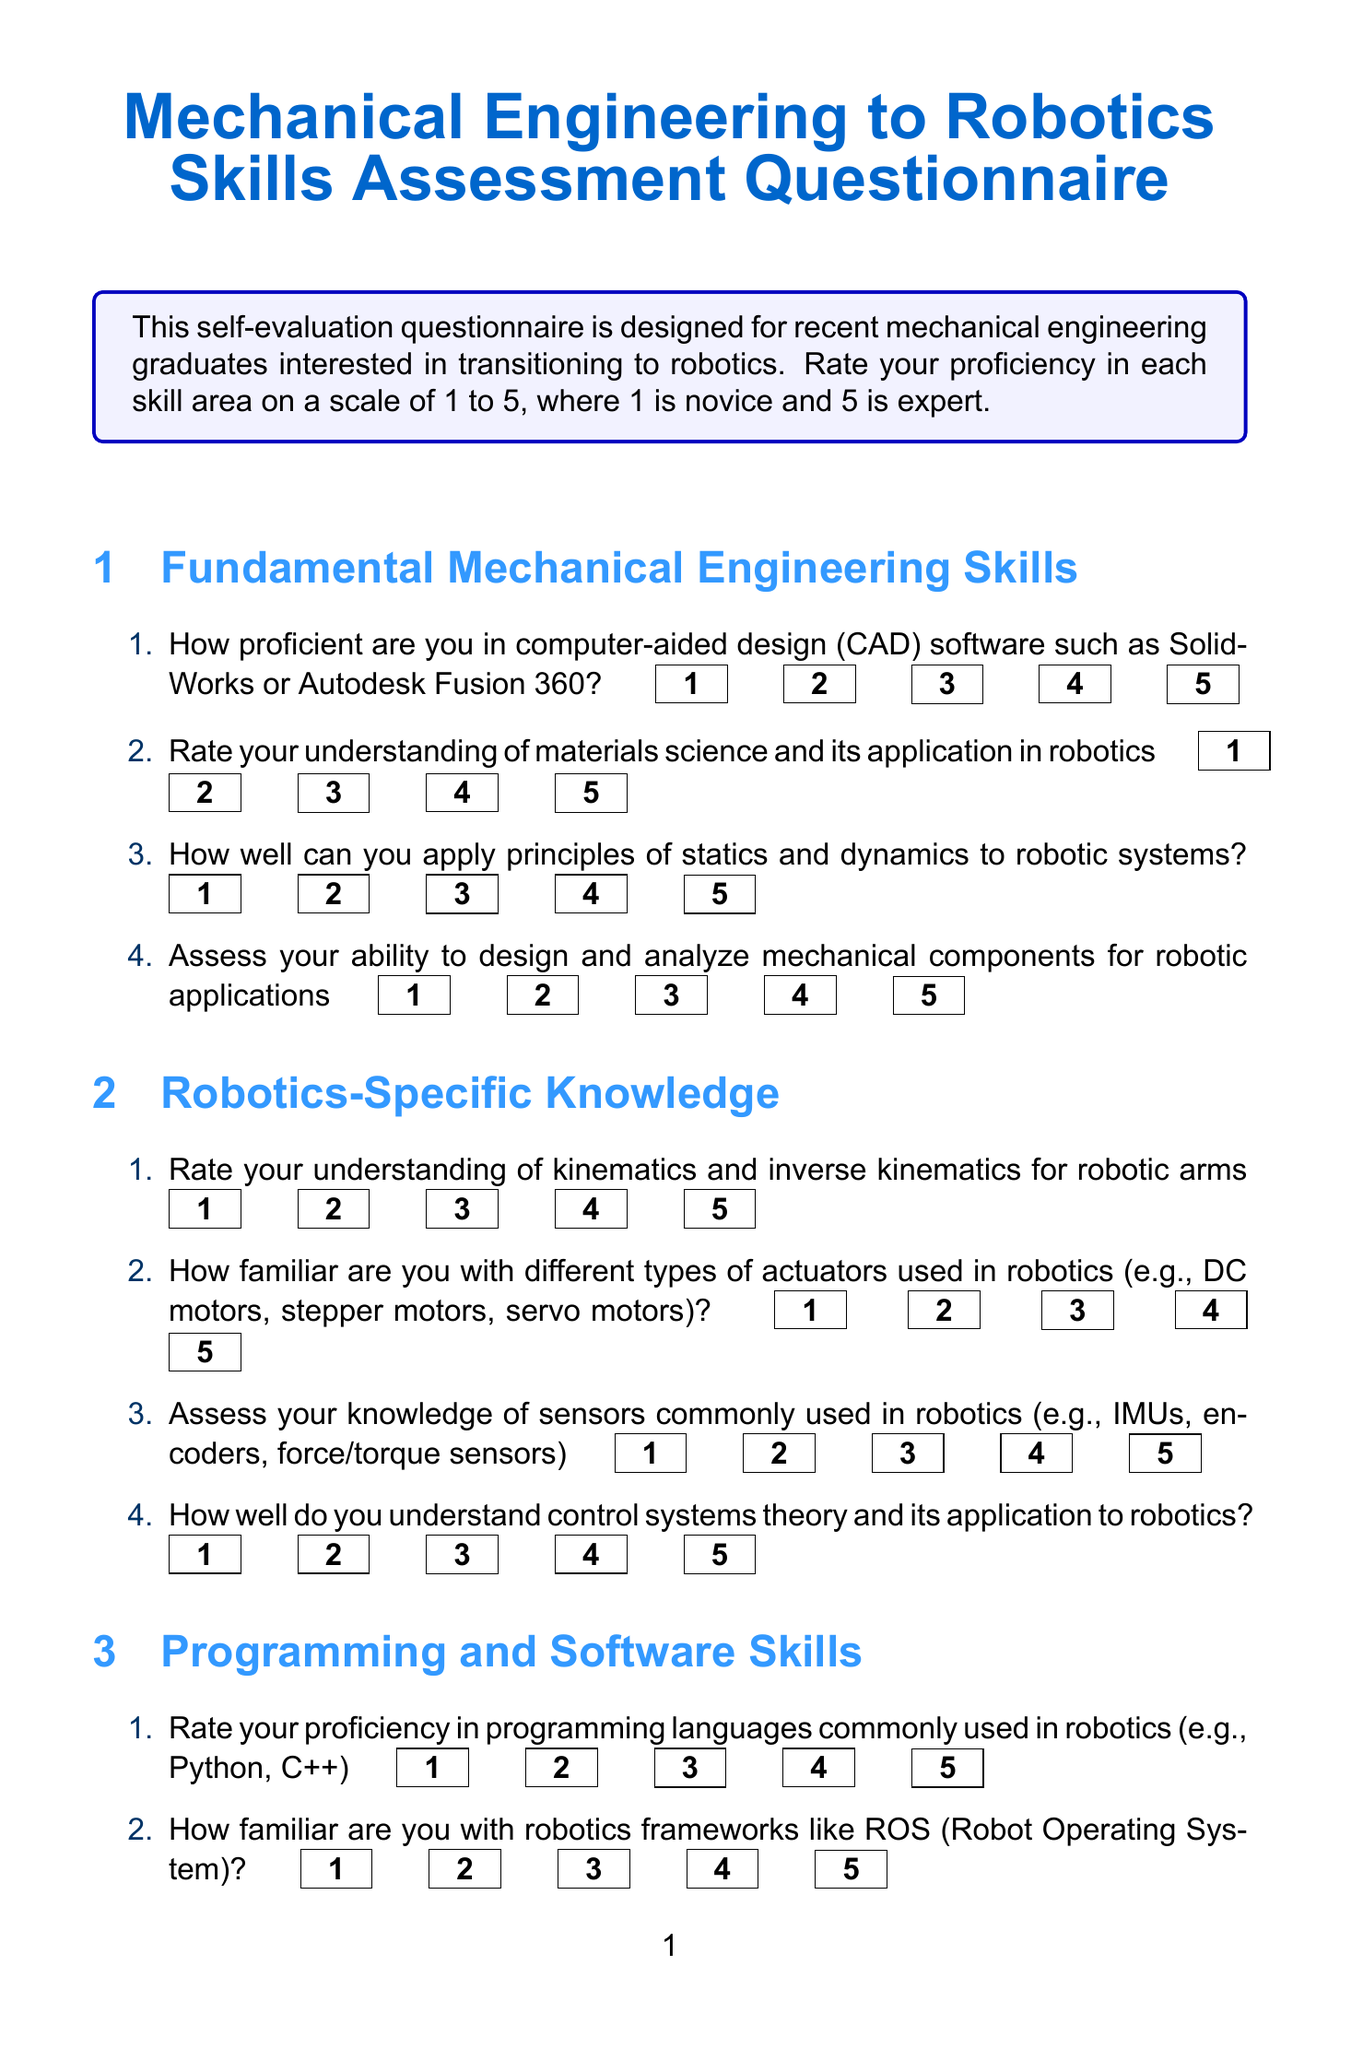What is the title of the document? The title of the document is explicitly stated at the beginning, which is indicated as "Mechanical Engineering to Robotics Skills Assessment Questionnaire."
Answer: Mechanical Engineering to Robotics Skills Assessment Questionnaire How many sections are there in the questionnaire? The document lists five distinct sections that make up the questionnaire.
Answer: 5 What is the maximum rating scale for self-evaluation? The questionnaire specifies a rating scale of 1 to 5 for proficiency assessment.
Answer: 5 Who is the author of the recommended book in resources? The name of the author for the recommended book is mentioned, which is stated as "John J. Craig".
Answer: John J. Craig What type of online course is suggested in the resources? The document specifies the suggested resource is an online course, particularly noted as "Coursera - Modern Robotics Specialization."
Answer: online_course How can you improve your skills according to the next steps? The next steps section provides several avenues for improvement, such as identifying areas for improvement based on self-assessment.
Answer: Identify areas for improvement What is one type of actuator mentioned in the Robotics-Specific Knowledge section? The document includes examples of actuators, one of which is a "DC motor."
Answer: DC motor What is the color of the section titles in the document? The section titles are formatted to be in a specific color emphasized in the document design, which is described as "sectioncolor."
Answer: sectioncolor 